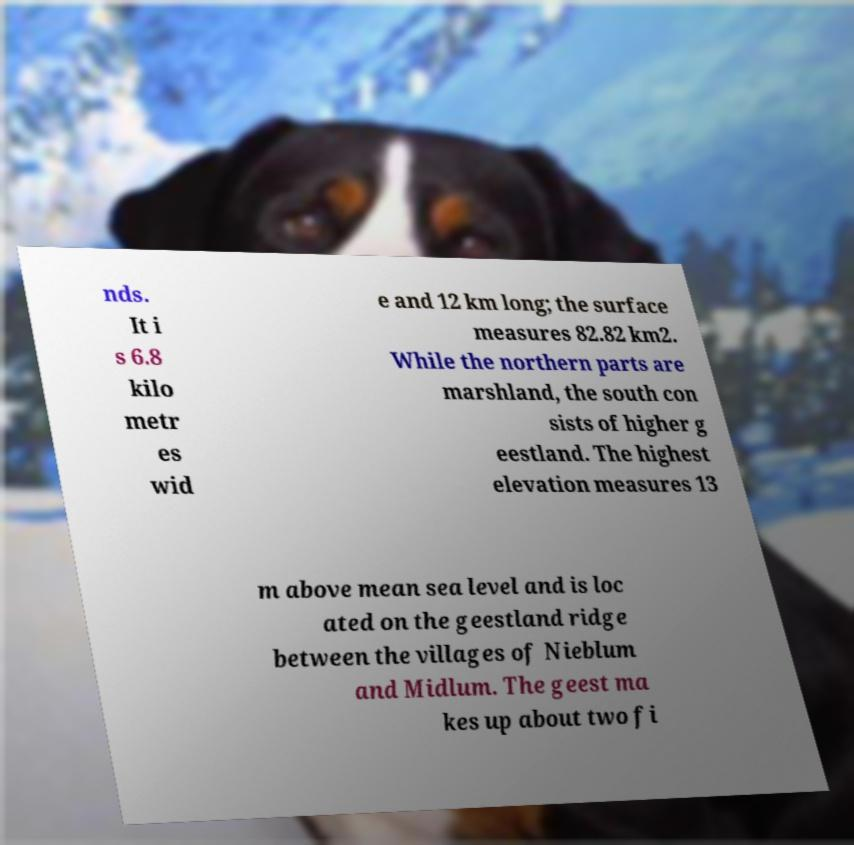There's text embedded in this image that I need extracted. Can you transcribe it verbatim? nds. It i s 6.8 kilo metr es wid e and 12 km long; the surface measures 82.82 km2. While the northern parts are marshland, the south con sists of higher g eestland. The highest elevation measures 13 m above mean sea level and is loc ated on the geestland ridge between the villages of Nieblum and Midlum. The geest ma kes up about two fi 